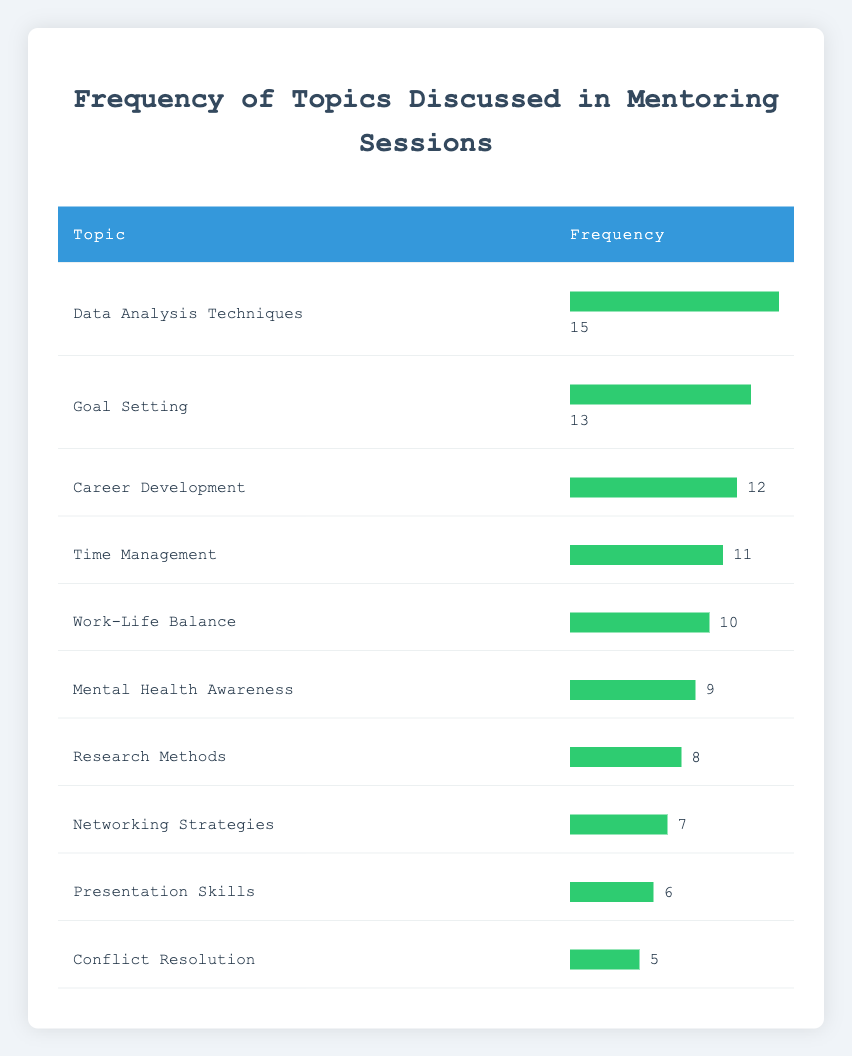What is the most frequently discussed topic in the mentoring sessions? The table lists the topics along with their frequencies. By examining the "Frequency" column, the highest frequency is 15, which corresponds to the topic "Data Analysis Techniques."
Answer: Data Analysis Techniques How many sessions focused on "Networking Strategies"? Looking at the table, the frequency for "Networking Strategies" is directly listed as 7 in the Frequency column.
Answer: 7 What is the total frequency of "Work-Life Balance" and "Mental Health Awareness"? To find this, we sum the frequencies of both topics. "Work-Life Balance" has a frequency of 10 and "Mental Health Awareness" has 9, so 10 + 9 = 19.
Answer: 19 Is there a topic with a frequency of exactly 6? By scanning the table, we can see that "Presentation Skills" has a frequency of 6. Therefore, the answer to the question is yes.
Answer: Yes What is the average frequency of the topics discussed in the mentoring sessions? To calculate the average, we first sum all the frequencies: 12 + 8 + 10 + 15 + 7 + 9 + 6 + 5 + 11 + 13 = 96. There are 10 topics, so the average is 96 / 10 = 9.6.
Answer: 9.6 Which topic had the least frequency, and how much was it? Scanning through the table, "Conflict Resolution" has the lowest frequency, which is 5.
Answer: Conflict Resolution, 5 How many more sessions discussed "Data Analysis Techniques" compared to "Research Methods"? The frequency for "Data Analysis Techniques" is 15, while for "Research Methods" it is 8. Therefore, the difference is 15 - 8 = 7.
Answer: 7 What is the total frequency of all topics excluding "Networking Strategies"? The frequency for "Networking Strategies" is 7. We first calculate the total sum of all frequencies (96), and then subtract 7 from it: 96 - 7 = 89.
Answer: 89 How many topics had a frequency greater than 10? Looking at the table, the topics with frequencies greater than 10 are "Data Analysis Techniques" (15), "Goal Setting" (13), "Career Development" (12), and "Time Management" (11), totaling 4 topics.
Answer: 4 